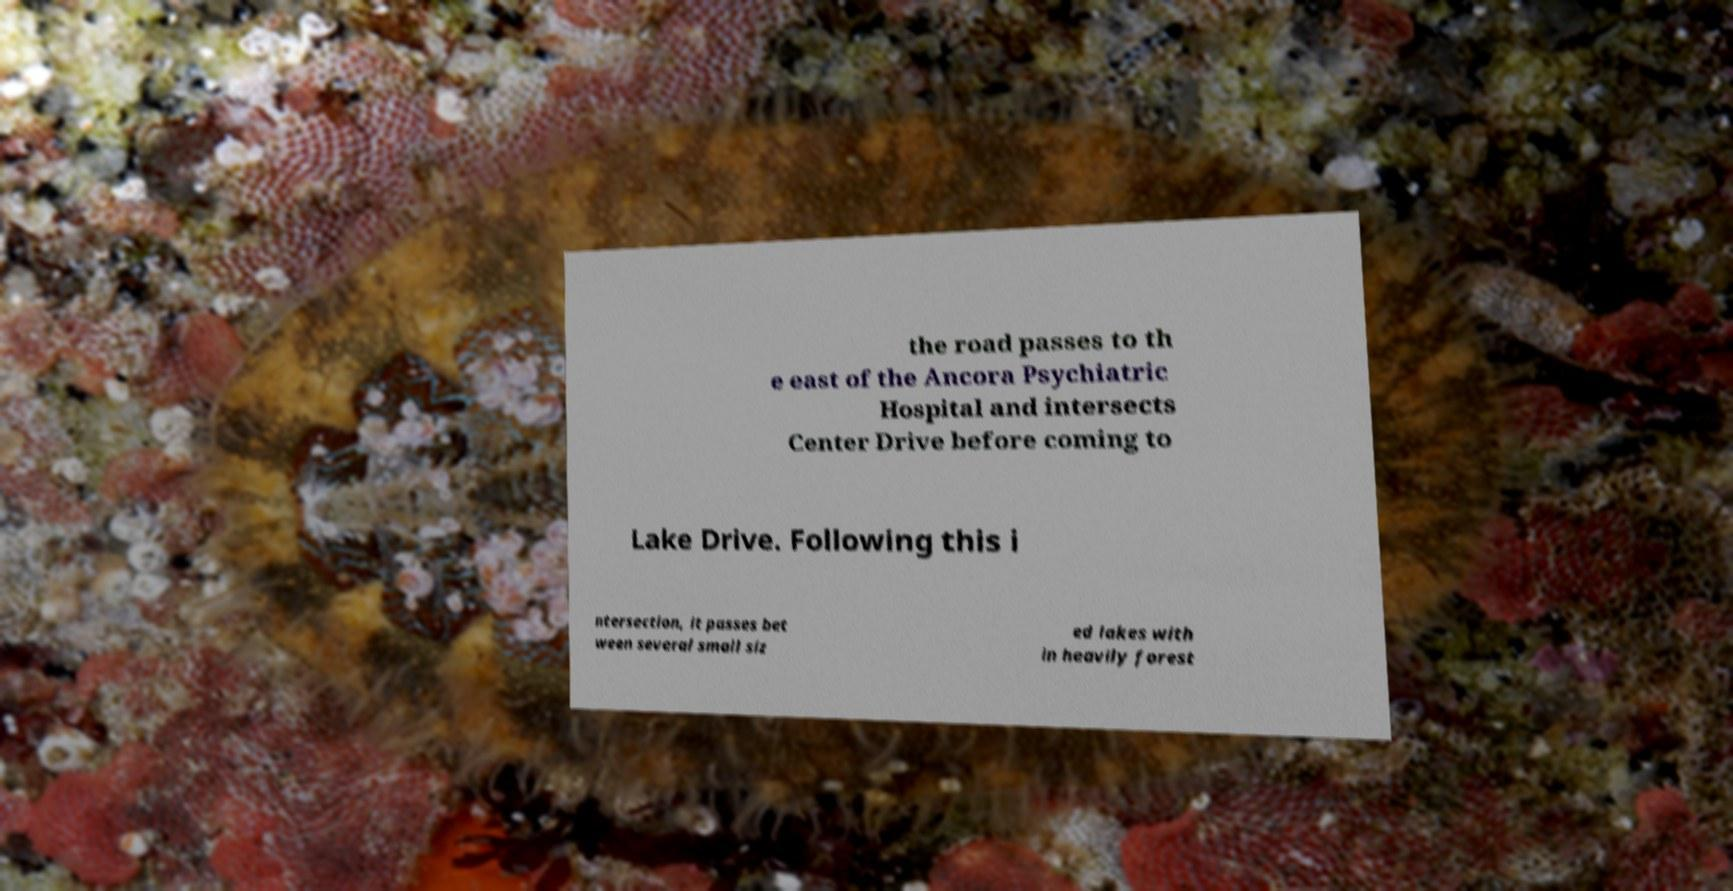Please identify and transcribe the text found in this image. the road passes to th e east of the Ancora Psychiatric Hospital and intersects Center Drive before coming to Lake Drive. Following this i ntersection, it passes bet ween several small siz ed lakes with in heavily forest 